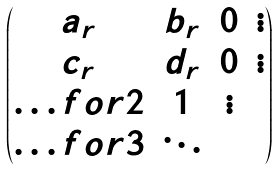Convert formula to latex. <formula><loc_0><loc_0><loc_500><loc_500>\begin{pmatrix} a _ { r } & b _ { r } & 0 & \vdots \\ c _ { r } & d _ { r } & 0 & \vdots \\ \hdots f o r { 2 } & 1 & \vdots \\ \hdots f o r { 3 } & \ddots \end{pmatrix}</formula> 